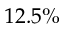<formula> <loc_0><loc_0><loc_500><loc_500>1 2 . 5 \%</formula> 